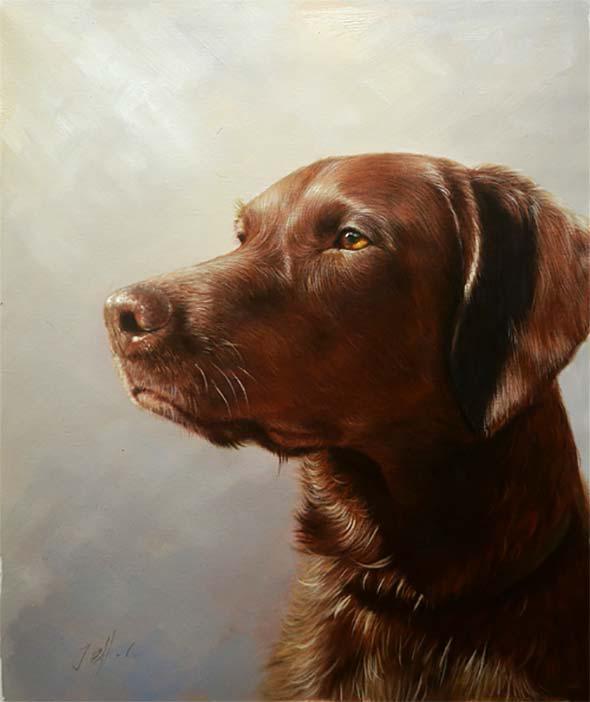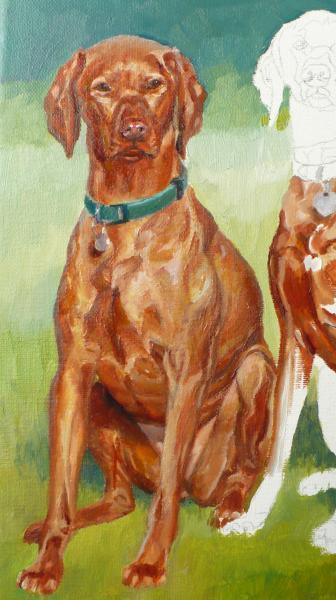The first image is the image on the left, the second image is the image on the right. Assess this claim about the two images: "The dog on the left is looking left and the dog on the right is looking straight ahead.". Correct or not? Answer yes or no. Yes. The first image is the image on the left, the second image is the image on the right. Evaluate the accuracy of this statement regarding the images: "The left image features a dog with its head turned to the left, and the right image features a dog sitting upright, gazing straight ahead, and wearing a collar with a tag dangling from it.". Is it true? Answer yes or no. Yes. 